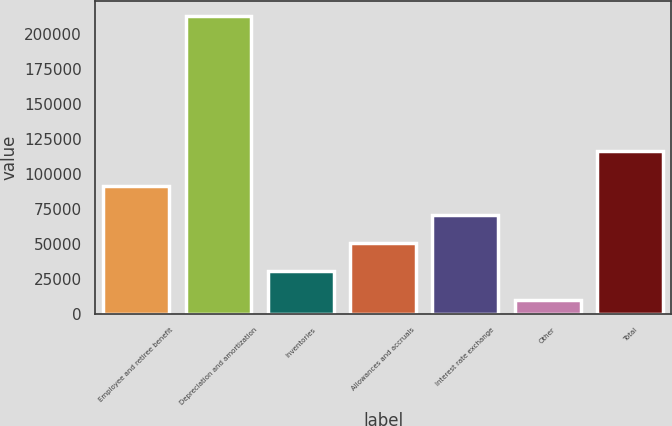<chart> <loc_0><loc_0><loc_500><loc_500><bar_chart><fcel>Employee and retiree benefit<fcel>Depreciation and amortization<fcel>Inventories<fcel>Allowances and accruals<fcel>Interest rate exchange<fcel>Other<fcel>Total<nl><fcel>91220.6<fcel>213002<fcel>30329.9<fcel>50626.8<fcel>70923.7<fcel>10033<fcel>116252<nl></chart> 